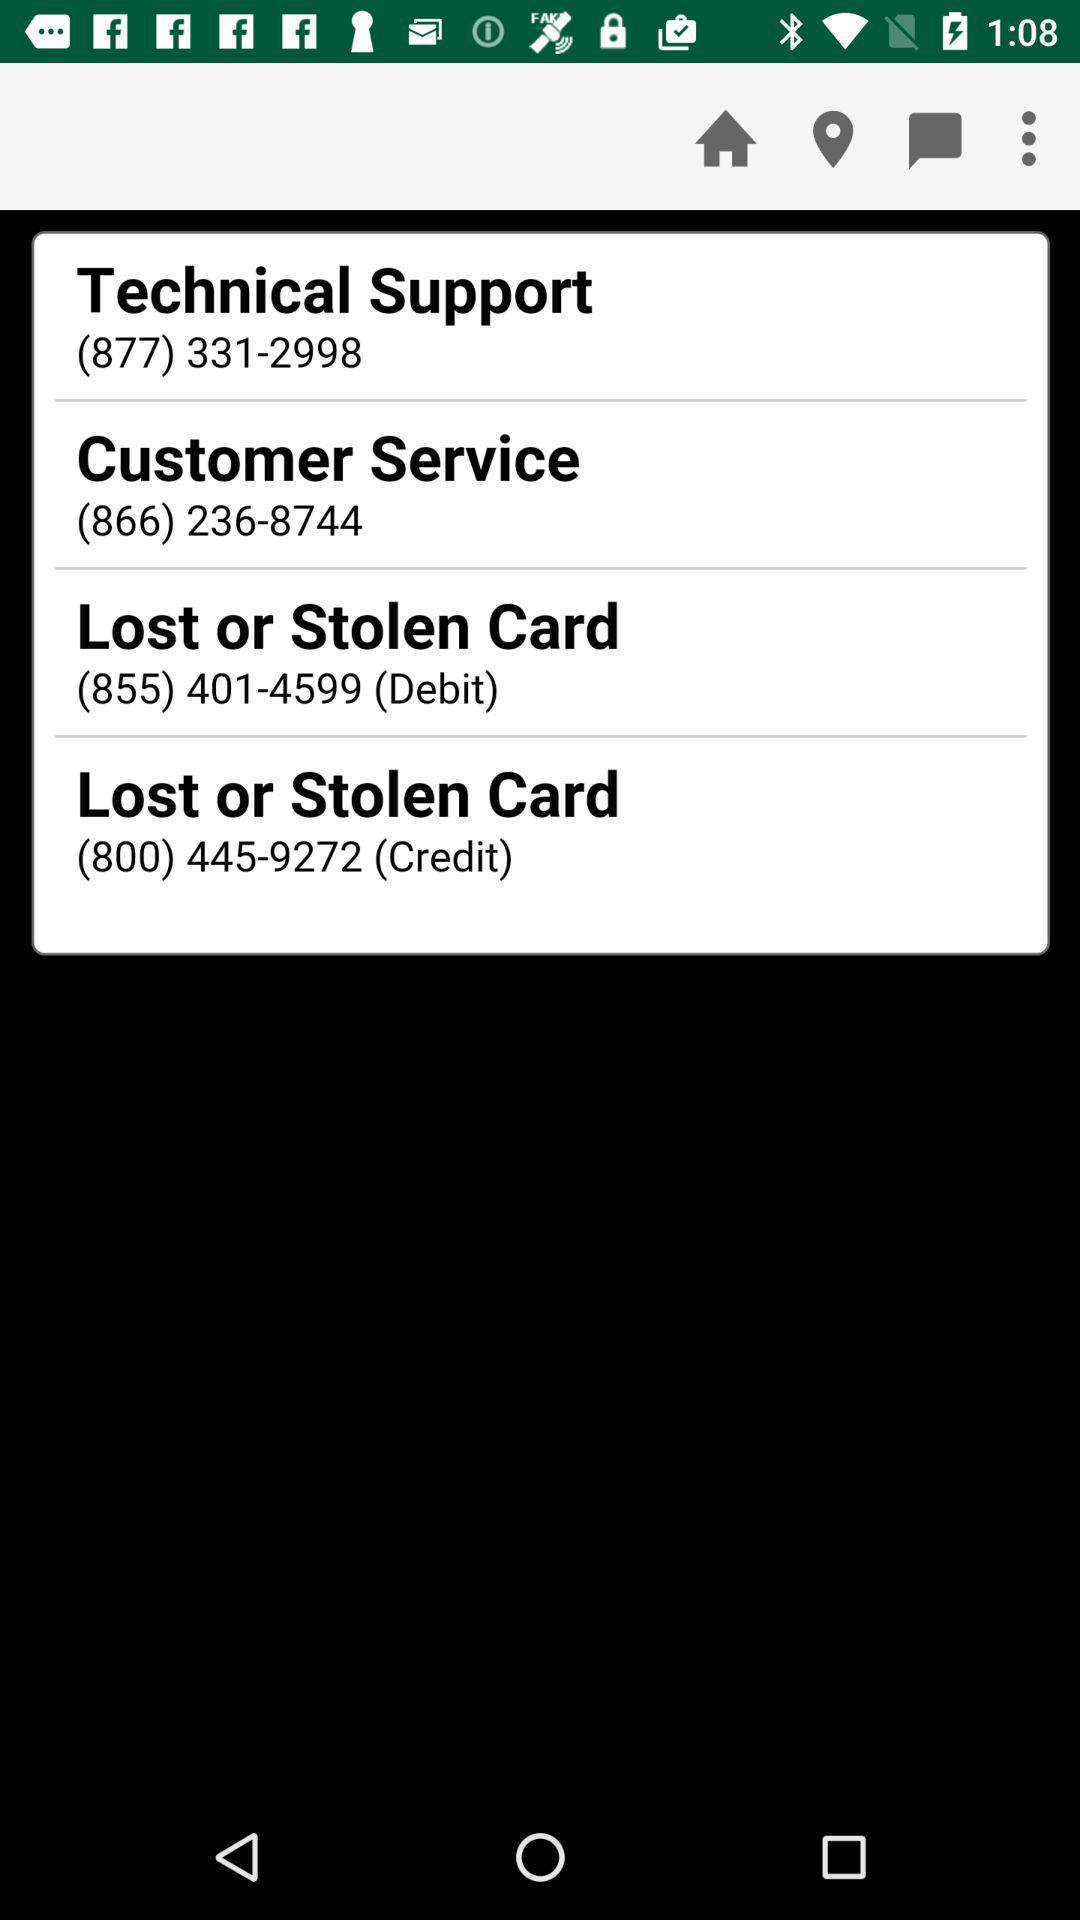What is the contact number for the support department to report a lost or stolen debit card? The contact number for the support department to report a lost or stolen debit card is (855) 401-4599. 